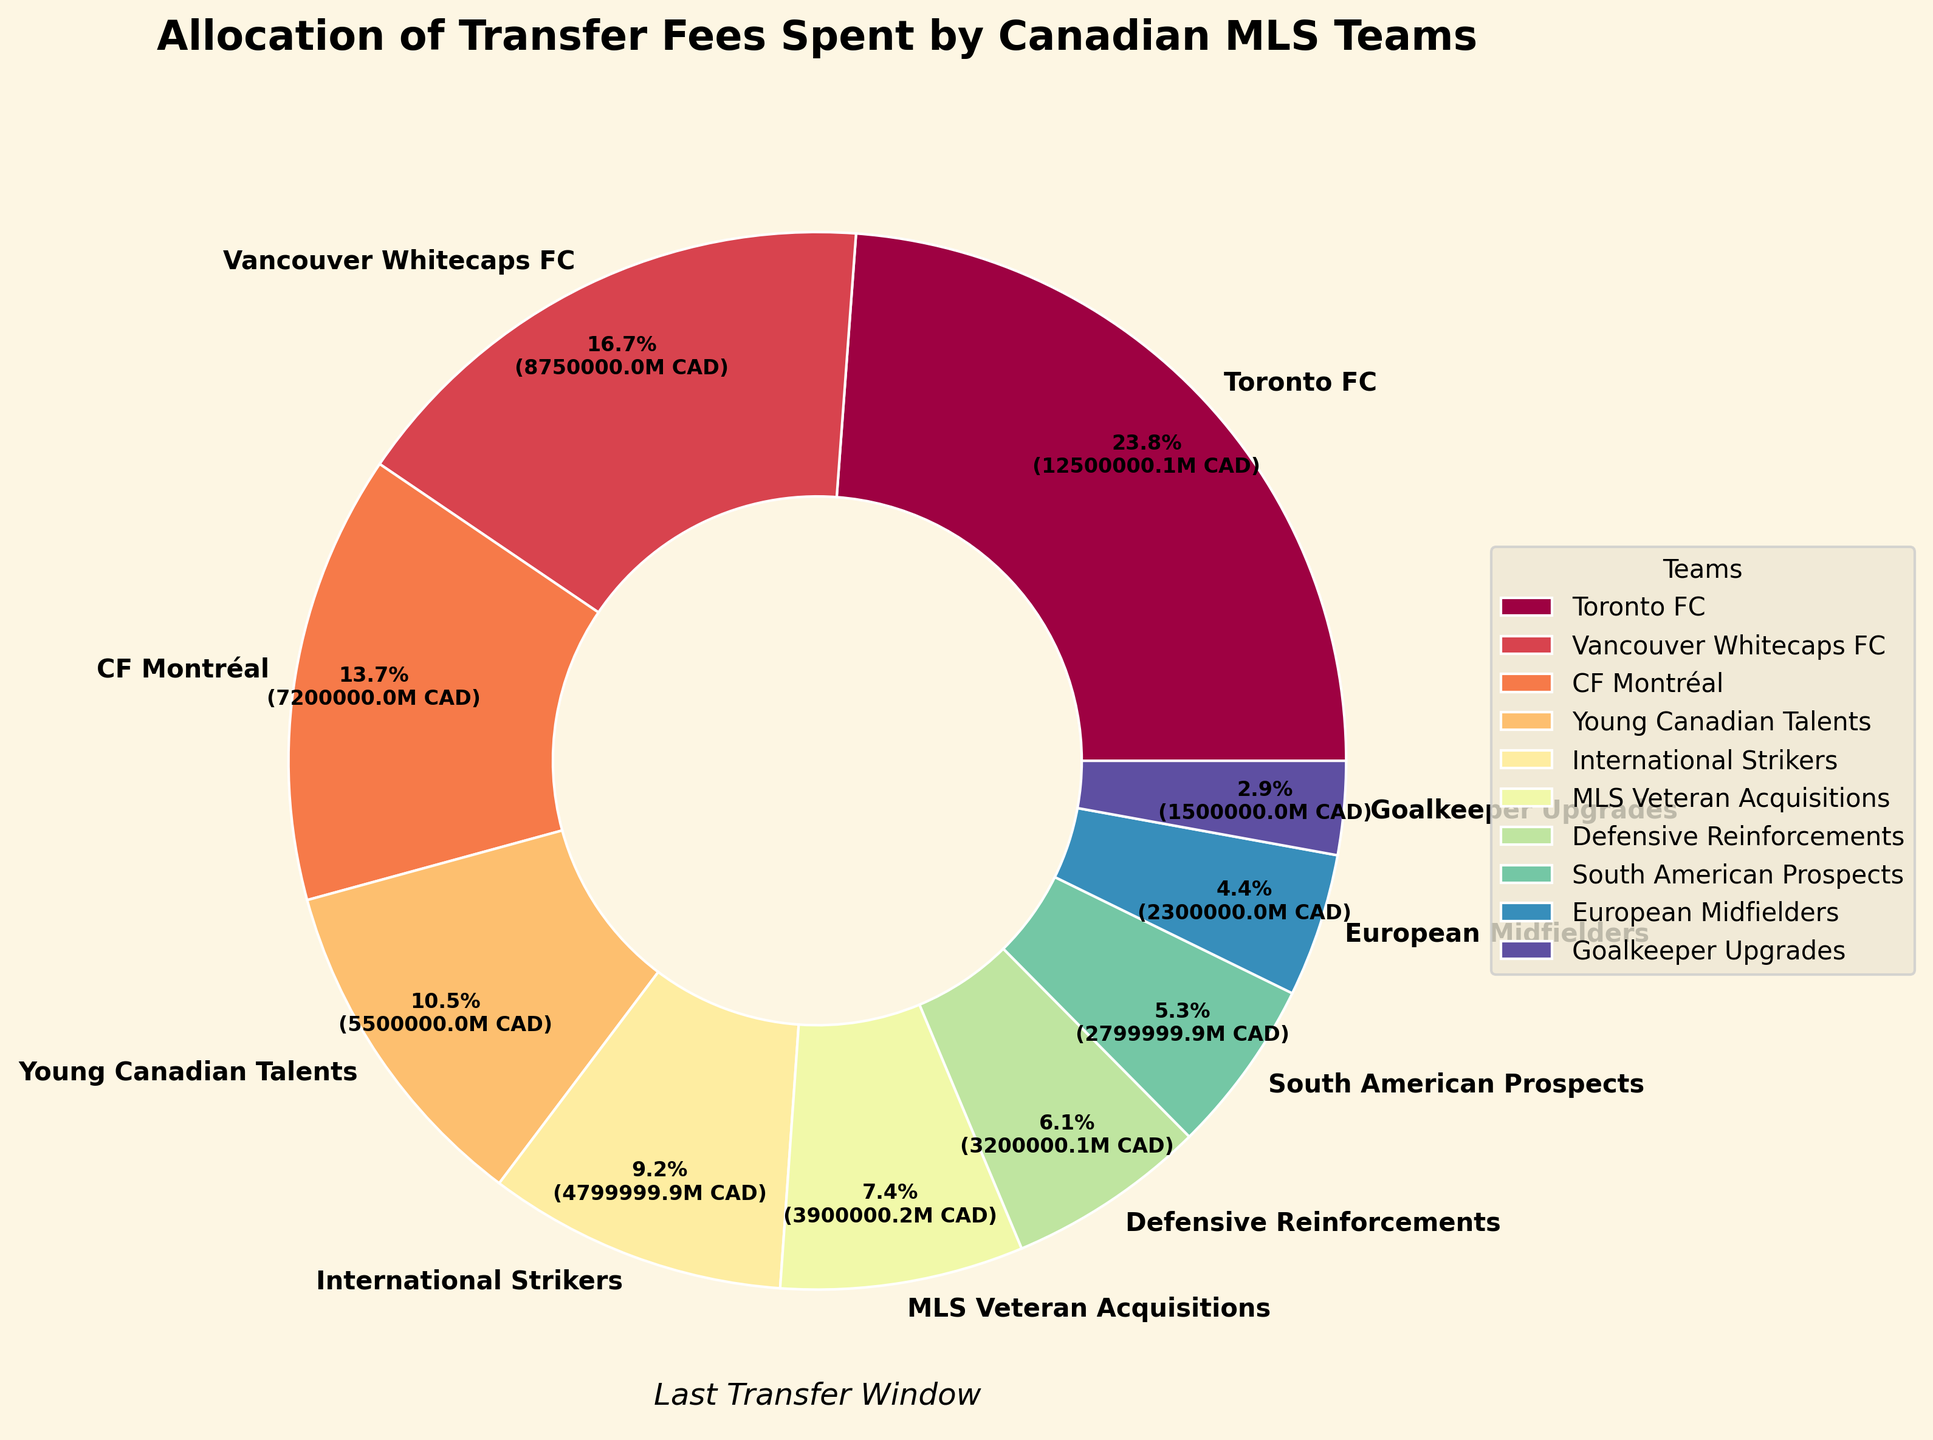What's the highest transfer fee allocation among the Canadian MLS teams? Toronto FC has the highest transfer fee spent at CAD 12,500,000, as shown in the pie chart.
Answer: Toronto FC Which category has the smallest transfer fee allocation? The segment labeled "Goalkeeper Upgrades" takes up the smallest portion of the pie chart, indicating CAD 1,500,000 spent.
Answer: Goalkeeper Upgrades How much more did Toronto FC spend compared to CF Montréal? Toronto FC spent CAD 12,500,000, and CF Montréal spent CAD 7,200,000. The difference is 12,500,000 - 7,200,000 = CAD 5,300,000.
Answer: CAD 5,300,000 What percentage of the total transfer fees did Vancouver Whitecaps FC account for? The pie chart shows Vancouver Whitecaps FC's segment at 8.75 million CAD. To find the percentage, we calculate (8,750,000 / total) * 100. The total is the sum of all segments: CAD 43,500,000. So, (8,750,000 / 43,500,000) * 100 ≈ 20.1%.
Answer: 20.1% Compare the transfer fees spent on “Young Canadian Talents” and “International Strikers.” The chart shows “Young Canadian Talents” has CAD 5,500,000, and “International Strikers” has CAD 4,800,000. The difference is 5,500,000 - 4,800,000 = CAD 700,000. “Young Canadian Talents” spent more.
Answer: Young Canadian Talents by CAD 700,000 What is the combined transfer fee spent by Vancouver Whitecaps FC and CF Montréal? Vancouver Whitecaps FC spent CAD 8,750,000, and CF Montréal spent CAD 7,200,000. Combined, they spent 8,750,000 + 7,200,000 = CAD 15,950,000.
Answer: CAD 15,950,000 Which segment of the pie chart occupies the most visual space? By observing the size of the segments, the Toronto FC segment is the largest and occupies the most visual space in the chart.
Answer: Toronto FC What's the total of the transfer fees spent by categories other than individual teams (i.e., other allocations)? Sum up "Young Canadian Talents" (CAD 5,500,000), "International Strikers" (CAD 4,800,000), "MLS Veteran Acquisitions" (CAD 3,900,000), "Defensive Reinforcements" (CAD 3,200,000), "South American Prospects" (CAD 2,800,000), "European Midfielders" (CAD 2,300,000), and "Goalkeeper Upgrades" (CAD 1,500,000). Total = 5,500,000 + 4,800,000 + 3,900,000 + 3,200,000 + 2,800,000 + 2,300,000 + 1,500,000 = CAD 24,000,000.
Answer: CAD 24,000,000 